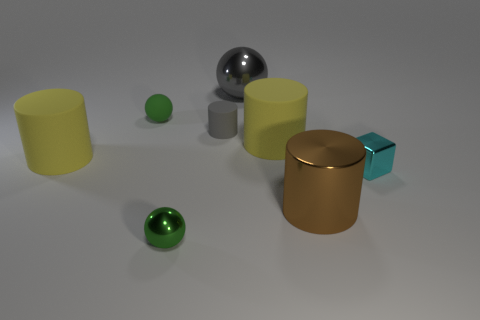Subtract all brown shiny cylinders. How many cylinders are left? 3 Subtract all gray cylinders. How many green balls are left? 2 Add 1 big spheres. How many objects exist? 9 Subtract all brown cylinders. How many cylinders are left? 3 Subtract all cubes. How many objects are left? 7 Subtract all gray cylinders. Subtract all red spheres. How many cylinders are left? 3 Add 8 large rubber cylinders. How many large rubber cylinders are left? 10 Add 7 big brown shiny balls. How many big brown shiny balls exist? 7 Subtract 1 gray cylinders. How many objects are left? 7 Subtract all tiny purple cylinders. Subtract all tiny matte balls. How many objects are left? 7 